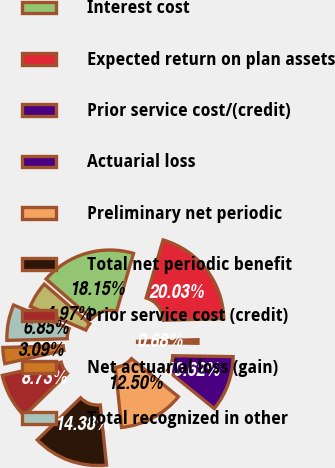Convert chart to OTSL. <chart><loc_0><loc_0><loc_500><loc_500><pie_chart><fcel>Service cost<fcel>Interest cost<fcel>Expected return on plan assets<fcel>Prior service cost/(credit)<fcel>Actuarial loss<fcel>Preliminary net periodic<fcel>Total net periodic benefit<fcel>Prior service cost (credit)<fcel>Net actuarial loss (gain)<fcel>Total recognized in other<nl><fcel>4.97%<fcel>18.15%<fcel>20.03%<fcel>0.68%<fcel>10.62%<fcel>12.5%<fcel>14.38%<fcel>8.73%<fcel>3.09%<fcel>6.85%<nl></chart> 